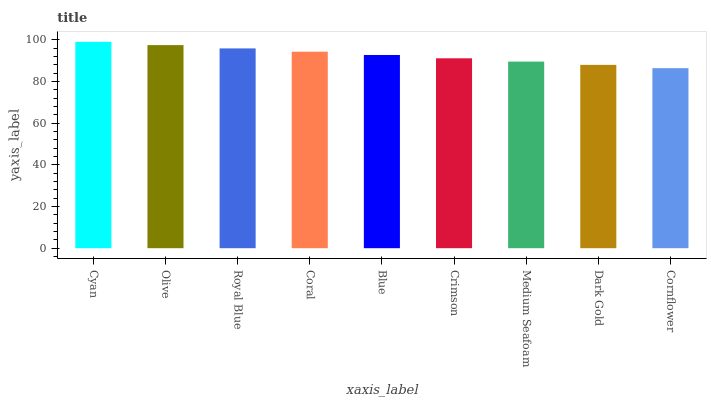Is Cornflower the minimum?
Answer yes or no. Yes. Is Cyan the maximum?
Answer yes or no. Yes. Is Olive the minimum?
Answer yes or no. No. Is Olive the maximum?
Answer yes or no. No. Is Cyan greater than Olive?
Answer yes or no. Yes. Is Olive less than Cyan?
Answer yes or no. Yes. Is Olive greater than Cyan?
Answer yes or no. No. Is Cyan less than Olive?
Answer yes or no. No. Is Blue the high median?
Answer yes or no. Yes. Is Blue the low median?
Answer yes or no. Yes. Is Cornflower the high median?
Answer yes or no. No. Is Olive the low median?
Answer yes or no. No. 